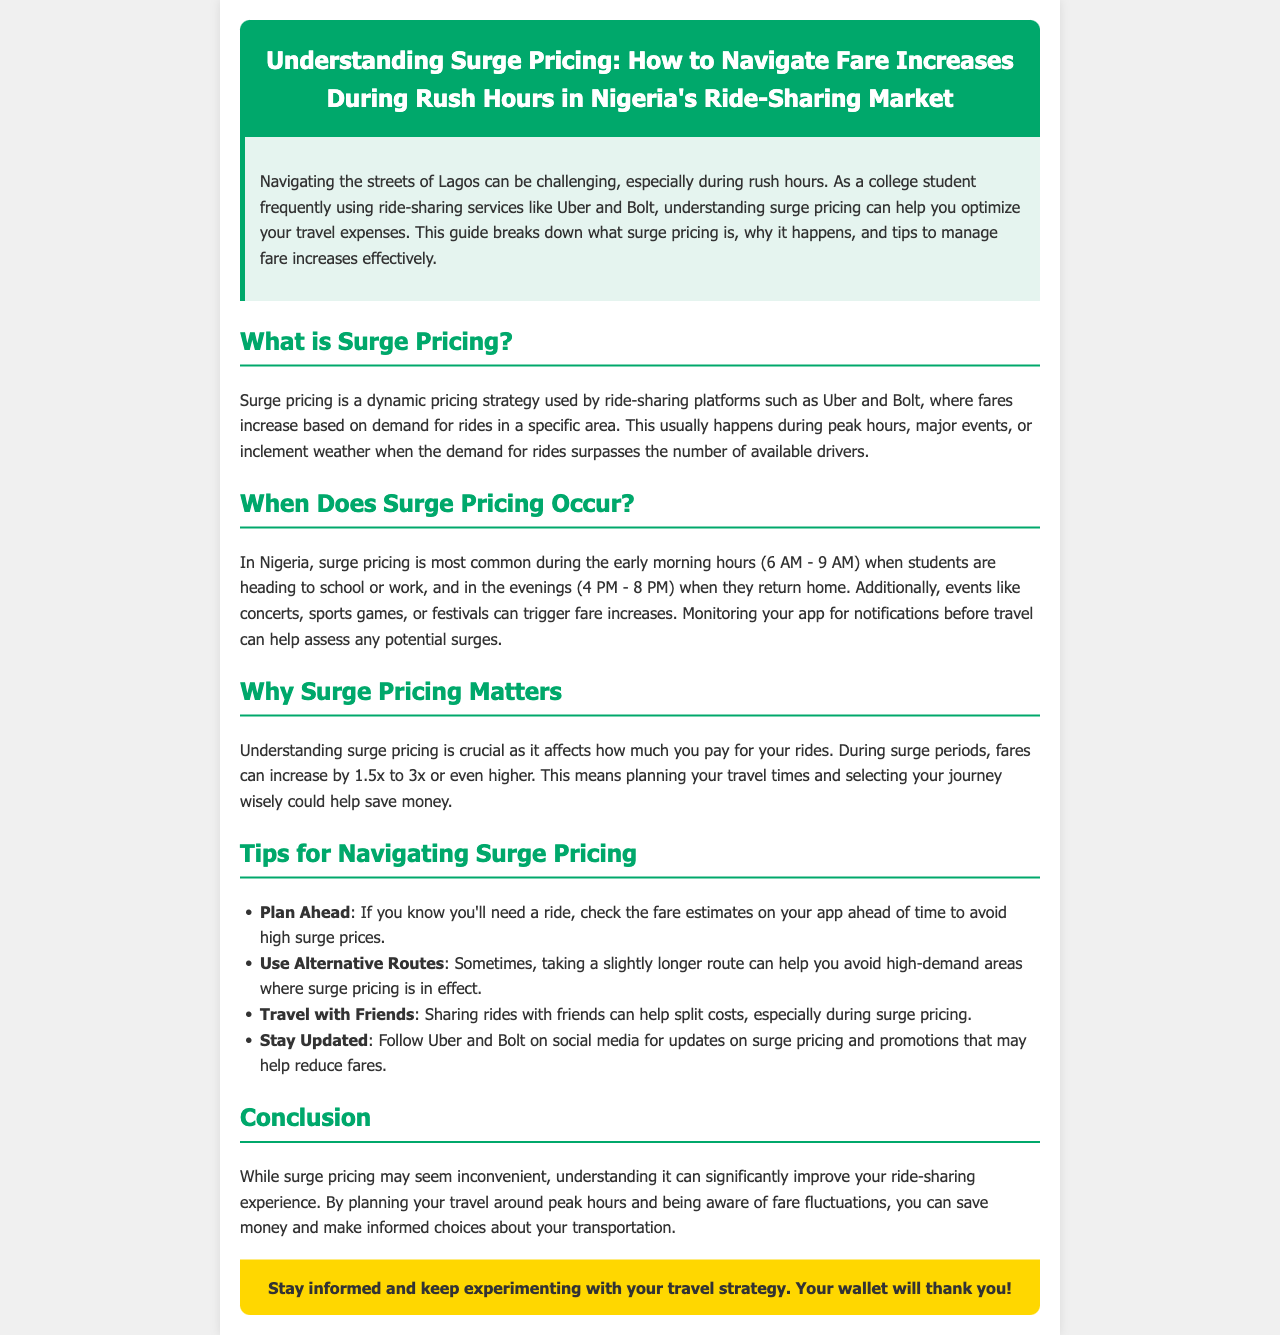What is surge pricing? Surge pricing is a dynamic pricing strategy used by ride-sharing platforms where fares increase based on demand for rides in a specific area.
Answer: A dynamic pricing strategy When does surge pricing occur in Nigeria? Surge pricing is most common during the early morning hours (6 AM - 9 AM) and in the evenings (4 PM - 8 PM).
Answer: 6 AM - 9 AM and 4 PM - 8 PM What is the fare increase multiplier during surge pricing? Fares can increase by 1.5x to 3x or even higher during surge periods.
Answer: 1.5x to 3x How can you avoid high surge prices? Checking fare estimates ahead of time can help avoid high surge prices.
Answer: Check fare estimates What is one benefit of sharing rides with friends? Sharing rides can help split costs, especially during surge pricing.
Answer: Split costs What should you do to stay updated on surge pricing? Follow Uber and Bolt on social media for updates on surge pricing and promotions.
Answer: Follow on social media What is the primary focus of the newsletter? The newsletter focuses on understanding surge pricing and how to navigate fare increases.
Answer: Understanding surge pricing What type of content does this document represent? The document is a newsletter aimed at educating readers.
Answer: A newsletter 